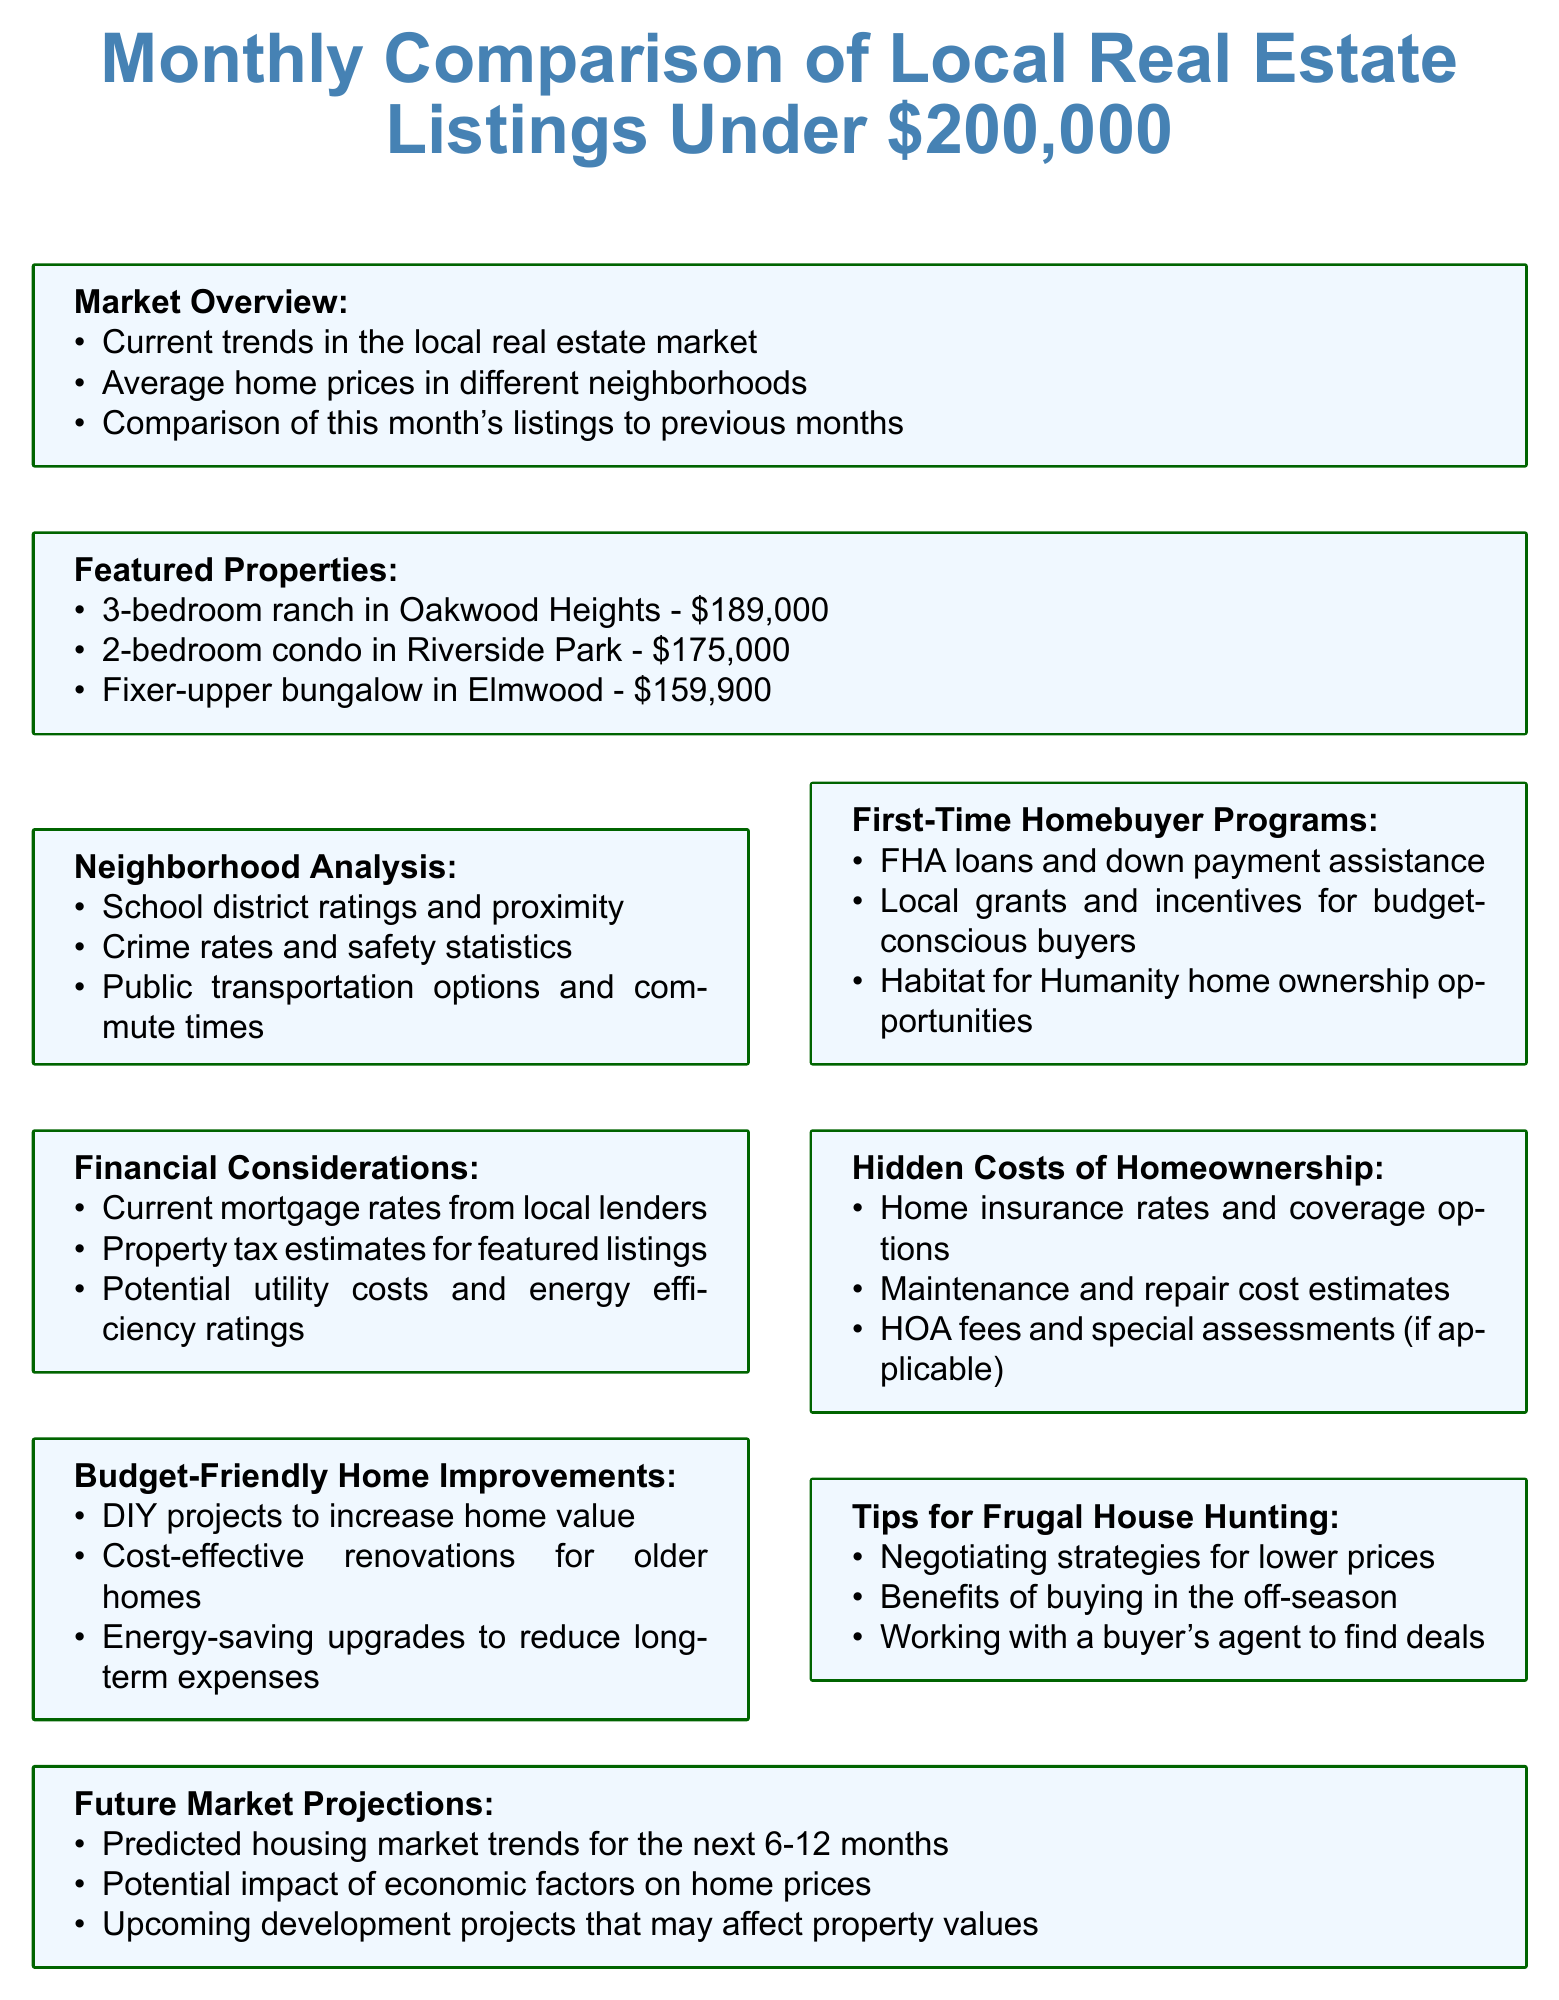What is the price of the 2-bedroom condo in Riverside Park? The price of the 2-bedroom condo is listed under the Featured Properties section of the document.
Answer: $175,000 What type of home is the fixer-upper in Elmwood? The document specifies the fixer-upper home in Elmwood as a bungalow.
Answer: Bungalow Which section discusses school district ratings? The Neighborhood Analysis section covers school district ratings and related topics.
Answer: Neighborhood Analysis What financial assistance program is mentioned for first-time homebuyers? The document outlines various programs in the First-Time Homebuyer Programs section.
Answer: FHA loans What are potential additional costs mentioned in the Hidden Costs of Homeownership section? The section lists various costs associated with homeownership, including maintenance and HOA fees.
Answer: Maintenance and HOA fees What is one benefit of buying a house in the off-season? The Tips for Frugal House Hunting section provides insights into advantages of timing in real estate purchases.
Answer: Lower prices What is the average price range of the featured properties under $200,000? By reviewing the prices of the featured properties, we can determine the average price.
Answer: About $174,300 Which resources are provided for budget-conscious homebuyers? The Resources for Budget-Conscious Homebuyers section lists various support options available to buyers.
Answer: Local financial advisors 